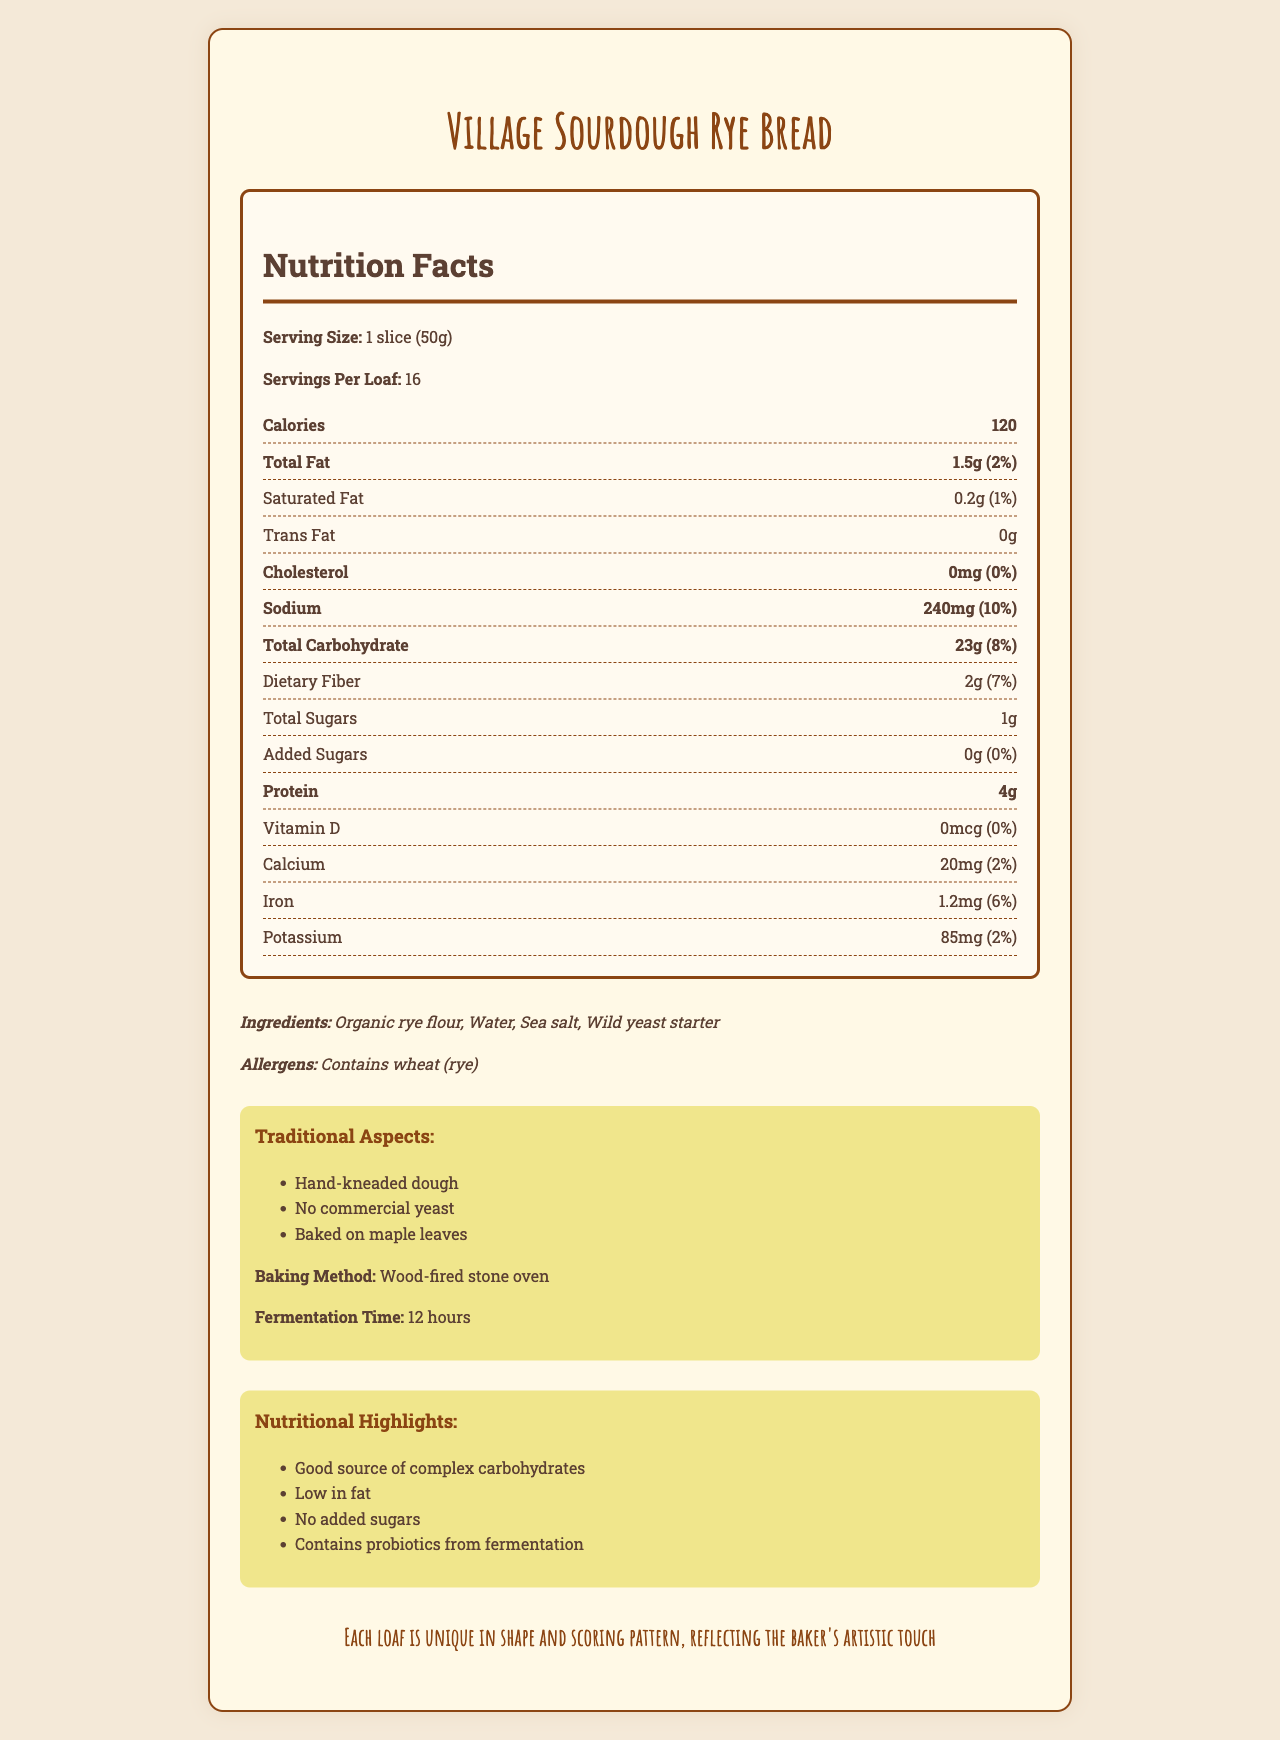what is the serving size for Village Sourdough Rye Bread? The serving size is clearly listed as 1 slice (50g) in the nutrition facts section.
Answer: 1 slice (50g) how many servings are there per loaf? The document states there are 16 servings per loaf.
Answer: 16 how much protein does each serving contain? Under the nutrition facts, protein content per serving is 4g.
Answer: 4g what is the fermentation time for Village Sourdough Rye Bread? It is mentioned under the traditional aspects and highlights sections as 12 hours.
Answer: 12 hours what ingredients are used in this bread? The ingredients section lists Organic rye flour, Water, Sea salt, and Wild yeast starter.
Answer: Organic rye flour, Water, Sea salt, Wild yeast starter which nutrient in this bread has the highest daily value percentage? Sodium has the highest daily value percentage at 10%.
Answer: Sodium how many calories are there per serving? The nutrition facts section lists 120 calories per serving.
Answer: 120 how is the bread baked? A. Electric oven B. Gas oven C. Wood-fired stone oven D. Microwave The bread is baked in a wood-fired stone oven as mentioned in the traditional aspects section.
Answer: C which of the following is NOT a nutritional highlight of this bread? A. Good source of complex carbohydrates B. High in sugar C. Low in fat D. Contains probiotics from fermentation Option B ("High in sugar") is not a nutritional highlight. The document states it is low in fat, a good source of complex carbohydrates, and contains probiotics from fermentation.
Answer: B does this bread contain added sugars? The nutrition facts section states that the bread has 0g of added sugars.
Answer: No describe the main idea of the document. The document gives a comprehensive overview of nutrition facts, traditional baking methods, and artisanal notes, emphasizing its simple ingredients and health benefits.
Answer: The main idea is to provide detailed nutritional information and traditional aspects of Village Sourdough Rye Bread, including its ingredients, baking method, and nutritional highlights. when was the village mill where the flour is sourced established? The document does not provide any information regarding when the village mill was established.
Answer: Cannot be determined 